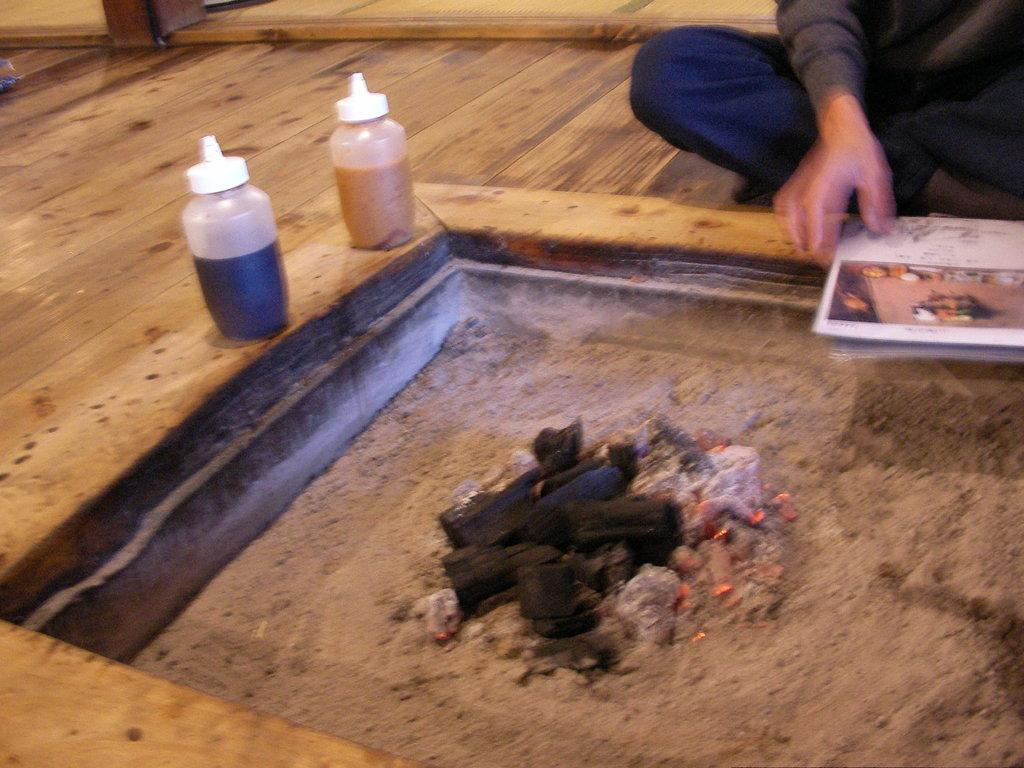What is the person in the image doing? The person is sitting on the floor in the image. What is the person holding while sitting on the floor? The person is holding a book. How many bottles can be seen in the image? There are 2 bottles visible in the image. What is the texture or substance present in the image? There is mud in the image. What type of leaf is being used as a decoration for the person's birthday in the image? There is no leaf or birthday celebration present in the image. 